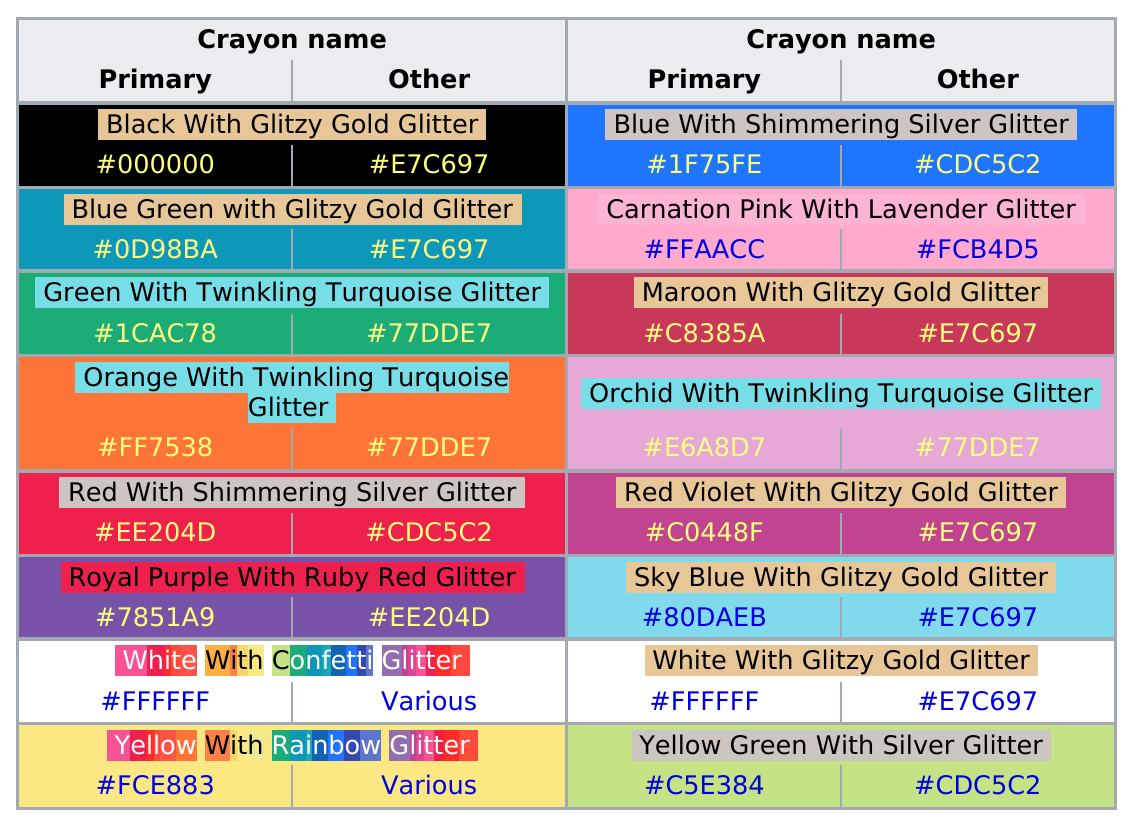Mention a couple of crucial points in this snapshot. The Crayola's crayons with glitter set includes a color of crayon with glitter, specifically ruby red glitter, and one of the colors is royal purple. The Crayola's Crayons with Glitter set includes 3 crayons, one of which is Twinkling Turquoise Glitter. 